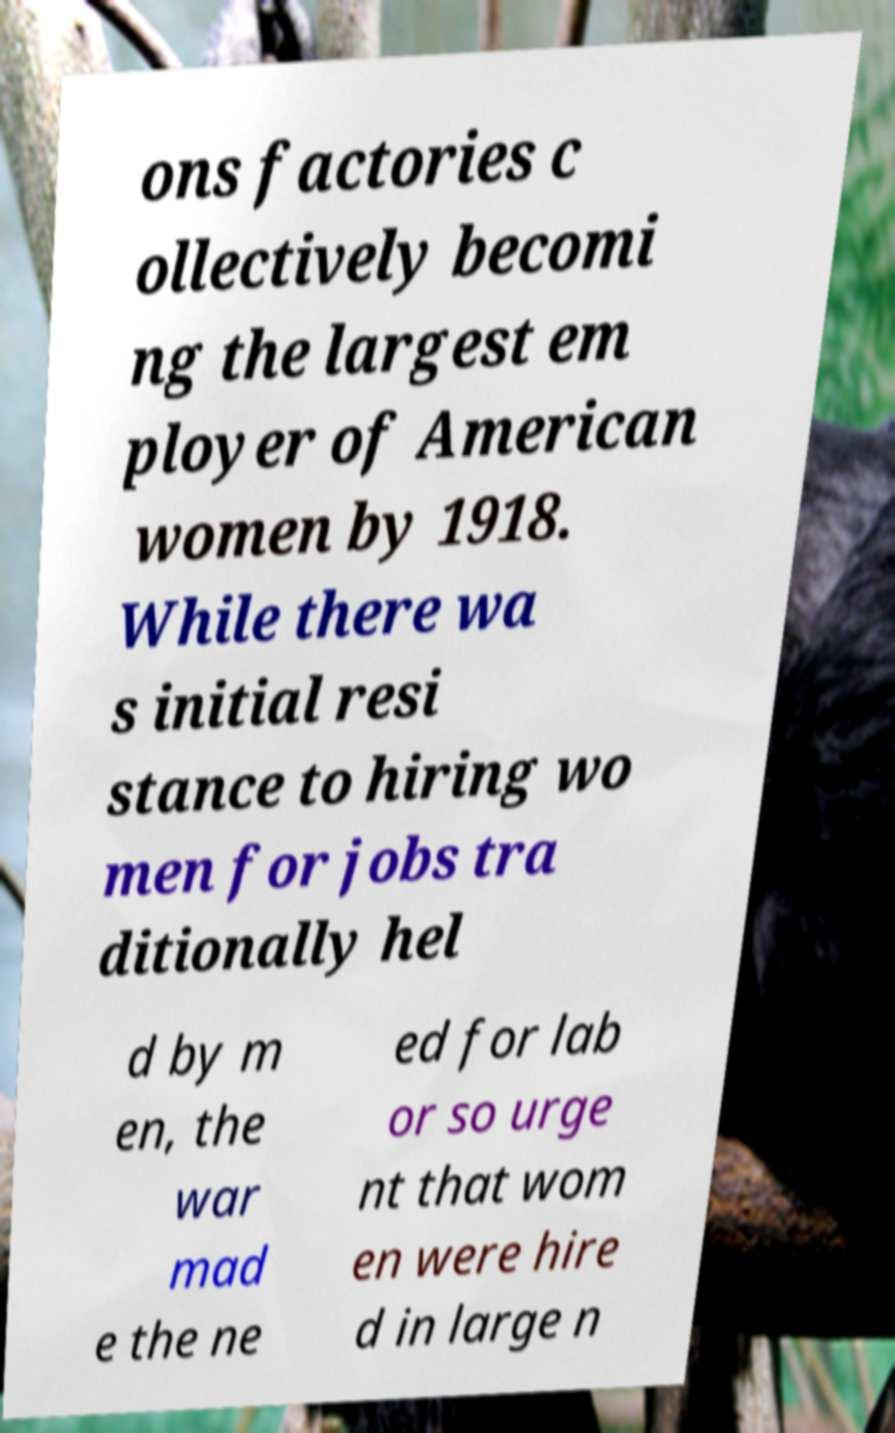Could you assist in decoding the text presented in this image and type it out clearly? ons factories c ollectively becomi ng the largest em ployer of American women by 1918. While there wa s initial resi stance to hiring wo men for jobs tra ditionally hel d by m en, the war mad e the ne ed for lab or so urge nt that wom en were hire d in large n 